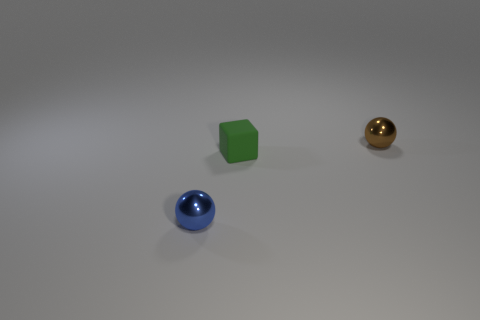What shapes can you see in this image? There are three distinct shapes visible: a blue sphere, a green cube, and a golden sphere. 